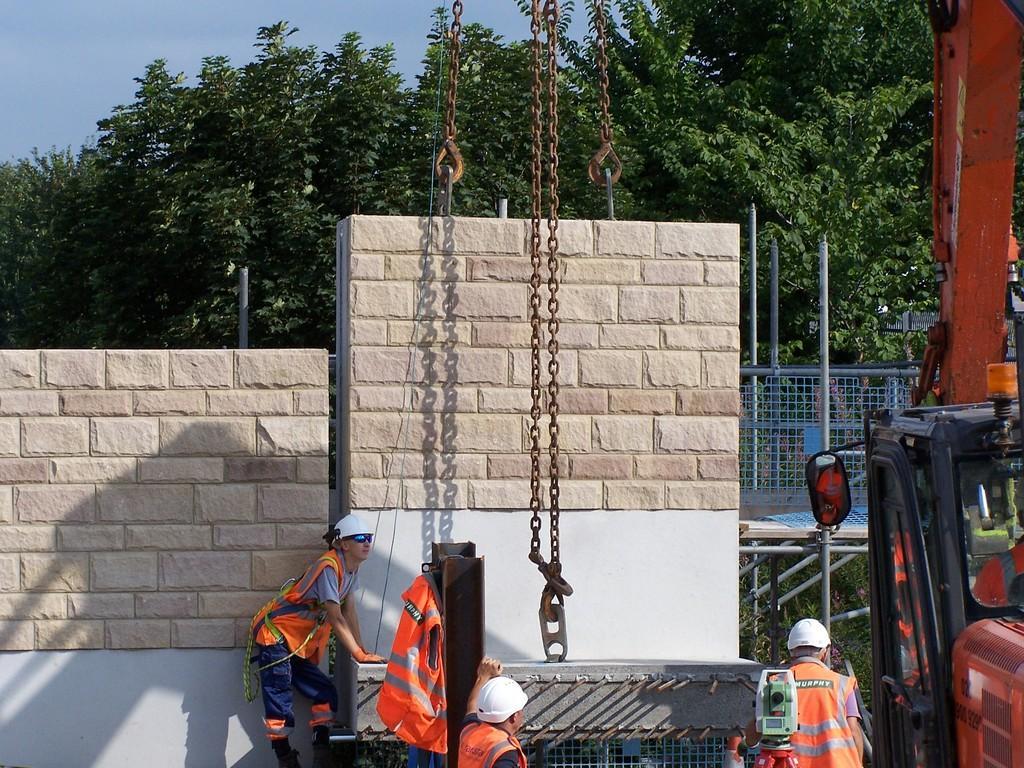In one or two sentences, can you explain what this image depicts? In this image I can see the group of people with orange color aprons and also white color helmets. To the right I can see the vehicle. In-front of these people I can see the metal chain. In the back there is a wall, trees and the blue sky. 